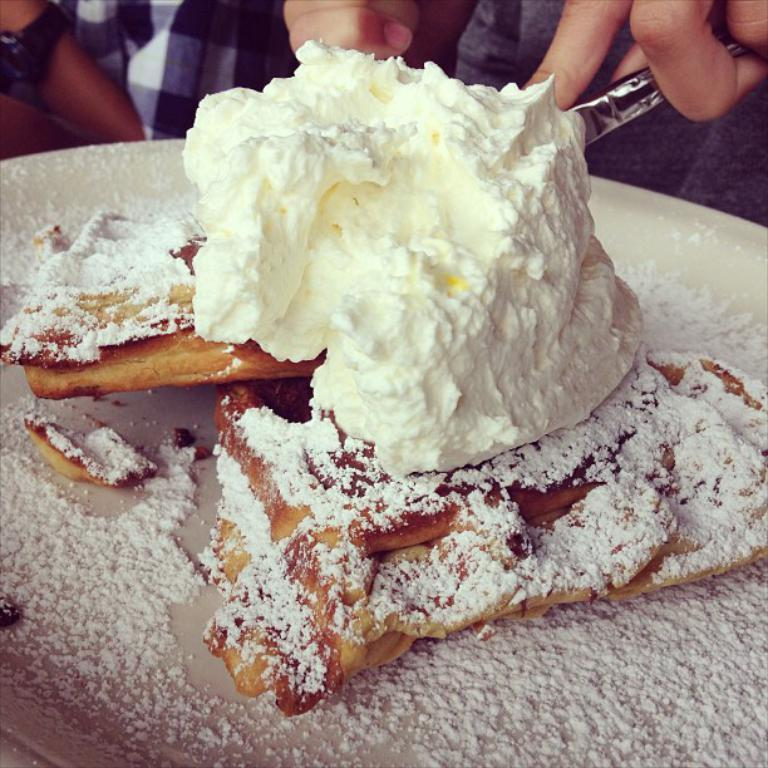What is on the bread in the image? There is creme on the bread in the image. Where are the creme and bread located in the image? The creme and bread are in the center of the image. What is the creme and bread placed on? The creme and bread are on a plate. Can you describe the people visible at the top side of the image? Unfortunately, the provided facts do not give any information about the people visible at the top side of the image. What type of fiction is the creme and bread a part of in the image? The creme and bread are not a part of any fiction in the image; they are a real food item. 